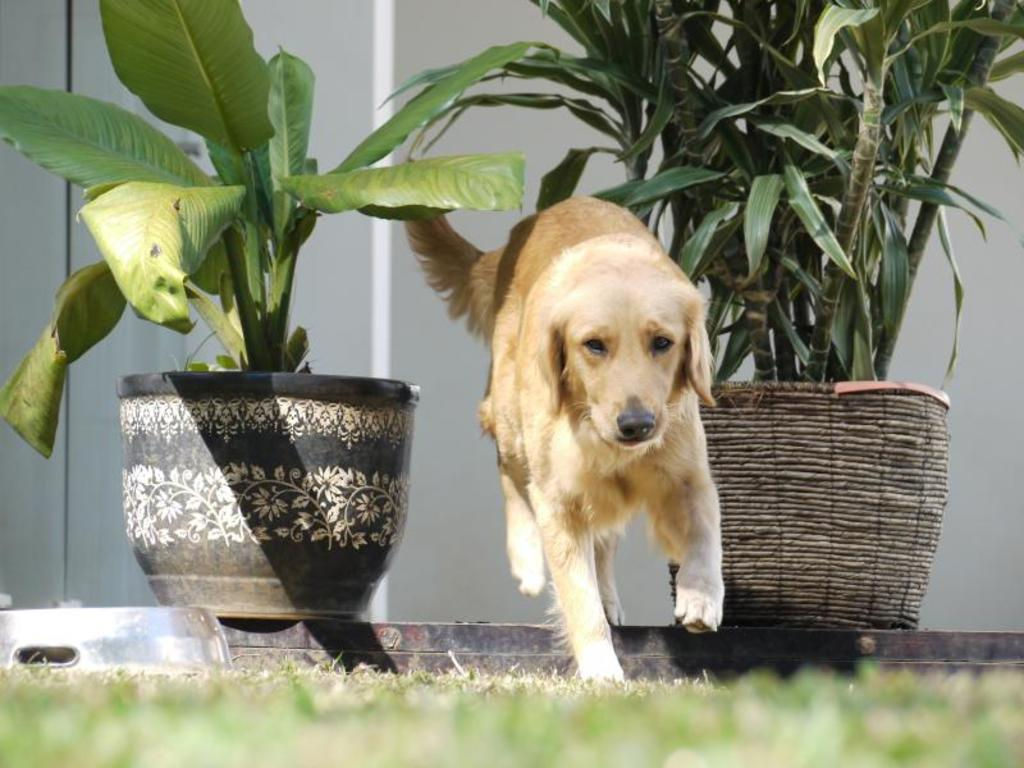What type of animal is present in the image? There is a dog in the image. What is the dog doing in the image? The dog is walking on a grass floor. What can be seen on either side of the dog? There are plant pots on either side of the dog. What is visible in the background of the image? There is a wall in the background of the image. What type of destruction can be seen caused by the animal in the image? There is no destruction caused by the animal in the image; the dog is simply walking on a grass floor. 